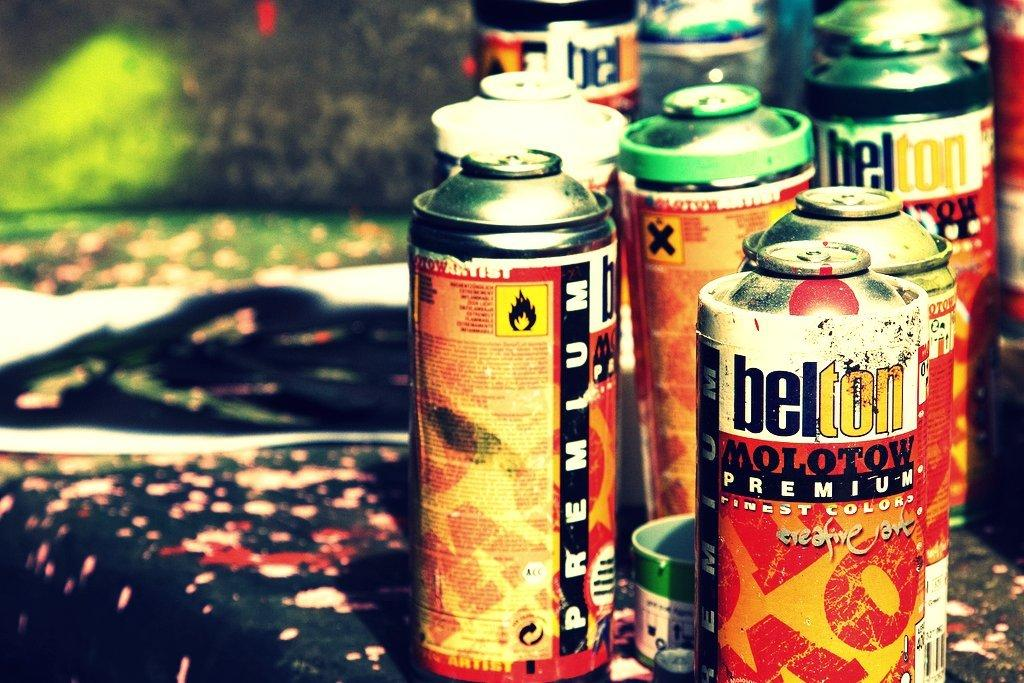<image>
Offer a succinct explanation of the picture presented. A couple of belton spray paint sitting on a table. 